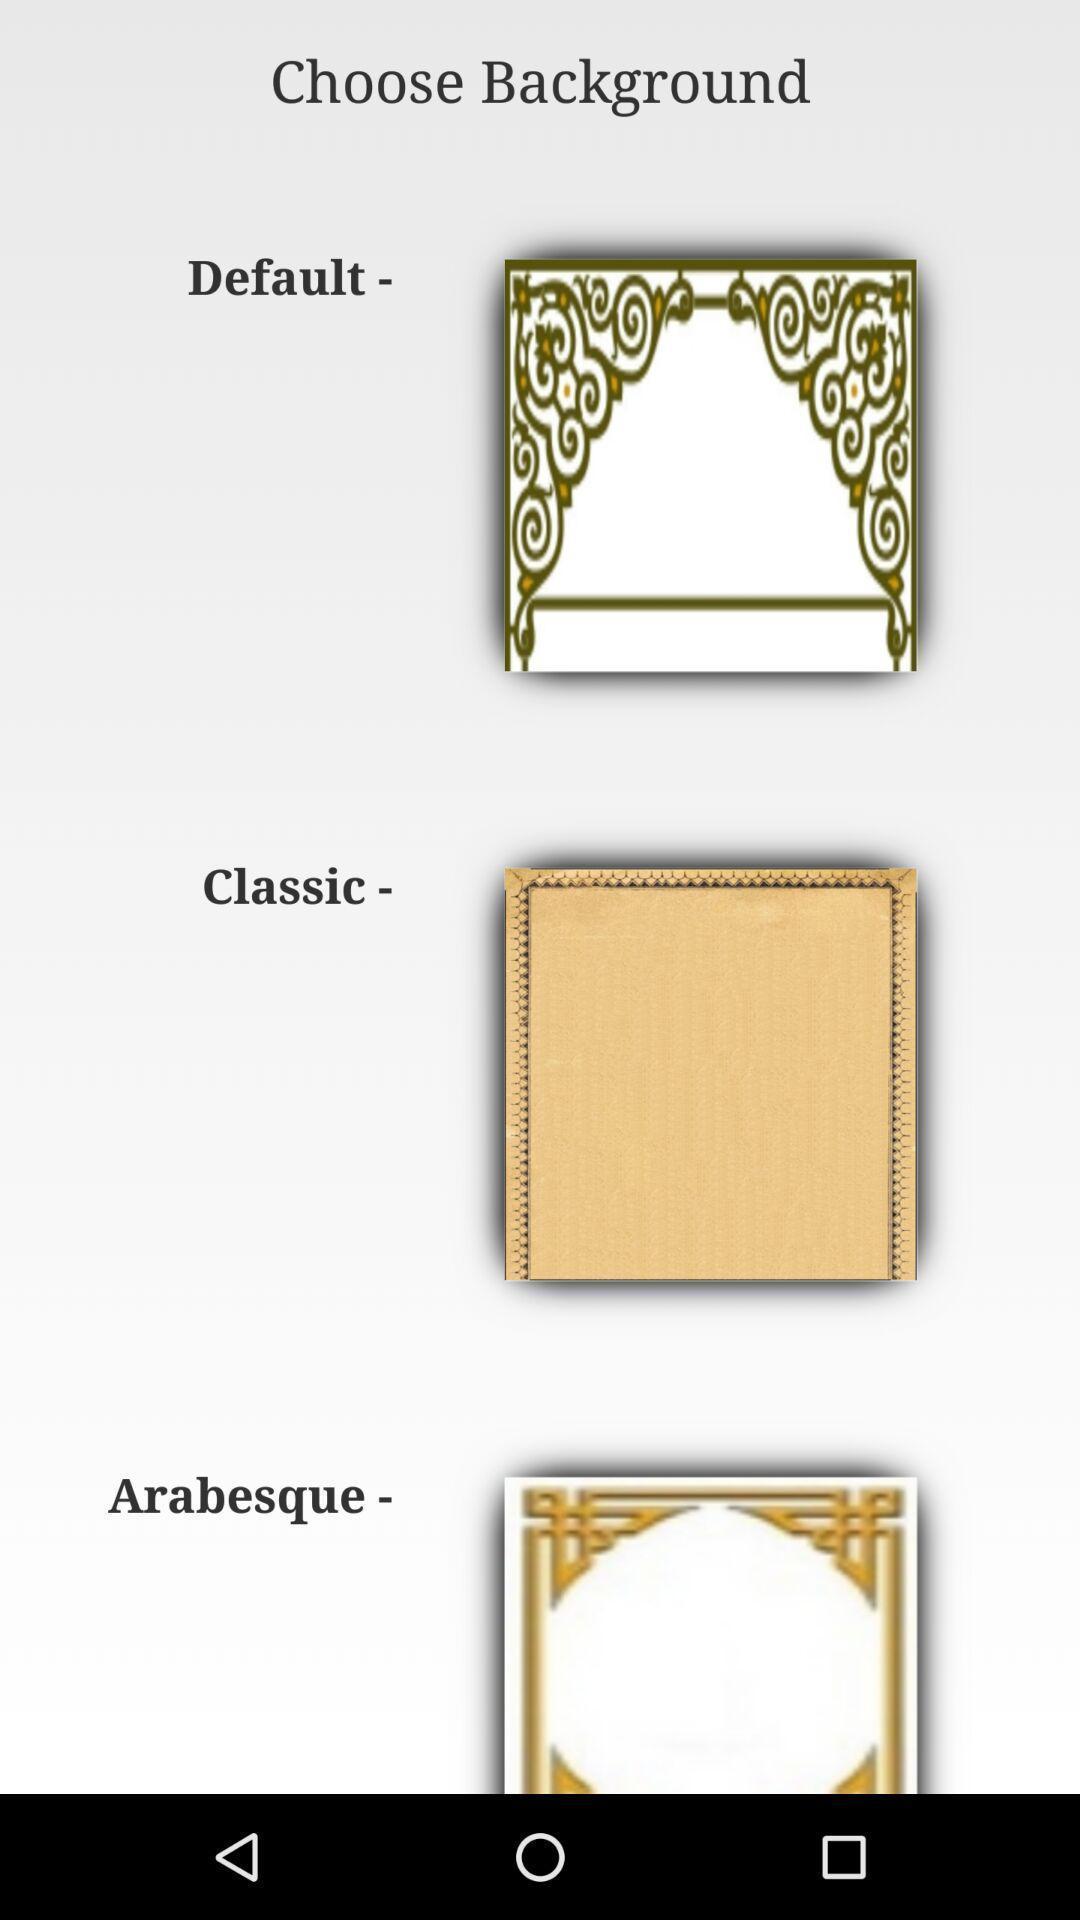Tell me what you see in this picture. Pages showing variety of background options. 